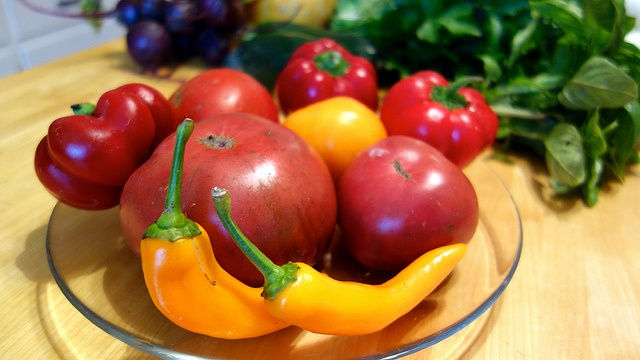Describe the objects in this image and their specific colors. I can see dining table in darkgray, khaki, and tan tones and bowl in darkgray, brown, maroon, and tan tones in this image. 